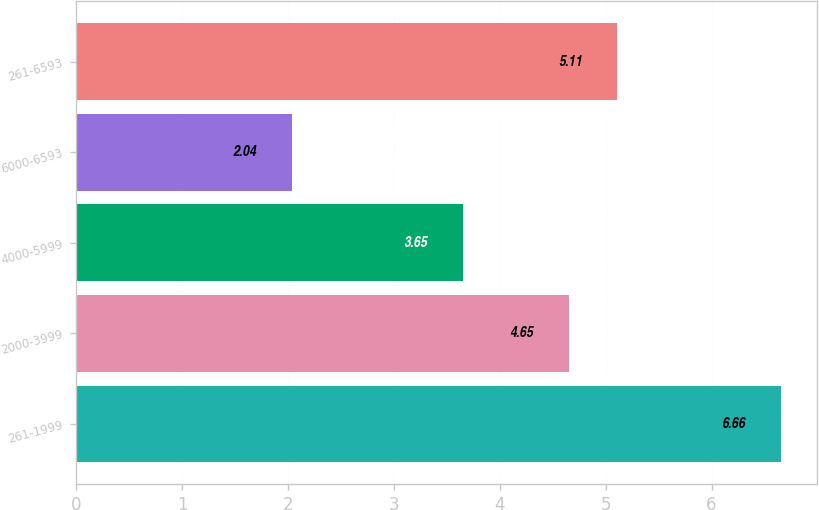Convert chart to OTSL. <chart><loc_0><loc_0><loc_500><loc_500><bar_chart><fcel>261-1999<fcel>2000-3999<fcel>4000-5999<fcel>6000-6593<fcel>261-6593<nl><fcel>6.66<fcel>4.65<fcel>3.65<fcel>2.04<fcel>5.11<nl></chart> 